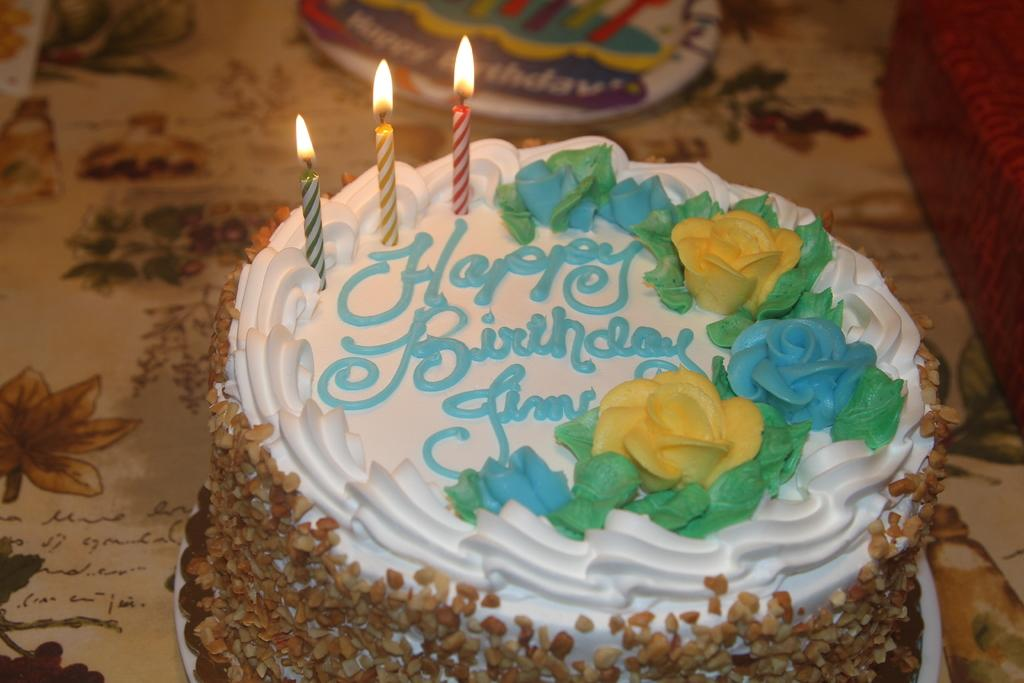What is the main subject of the image? There is a cake in the image. How is the cake positioned in the image? The cake is on a plate. Where is the plate with the cake located? The plate with the cake is placed on a table. What can be seen on top of the cake? There are three candles with flames in the image. What type of crown can be seen on the tree in the image? There is no crown or tree present in the image; it only features a cake with candles on a plate placed on a table. 